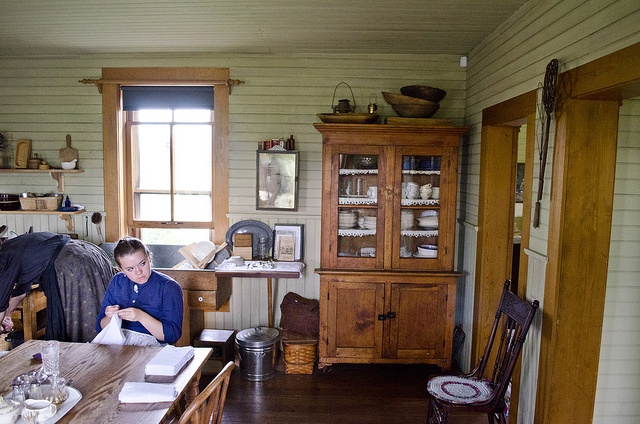Describe the objects in this image and their specific colors. I can see dining table in gray, darkgray, and lavender tones, people in gray, black, and darkgray tones, chair in gray, black, maroon, and darkgray tones, people in gray, navy, darkblue, lavender, and pink tones, and chair in gray, brown, and black tones in this image. 